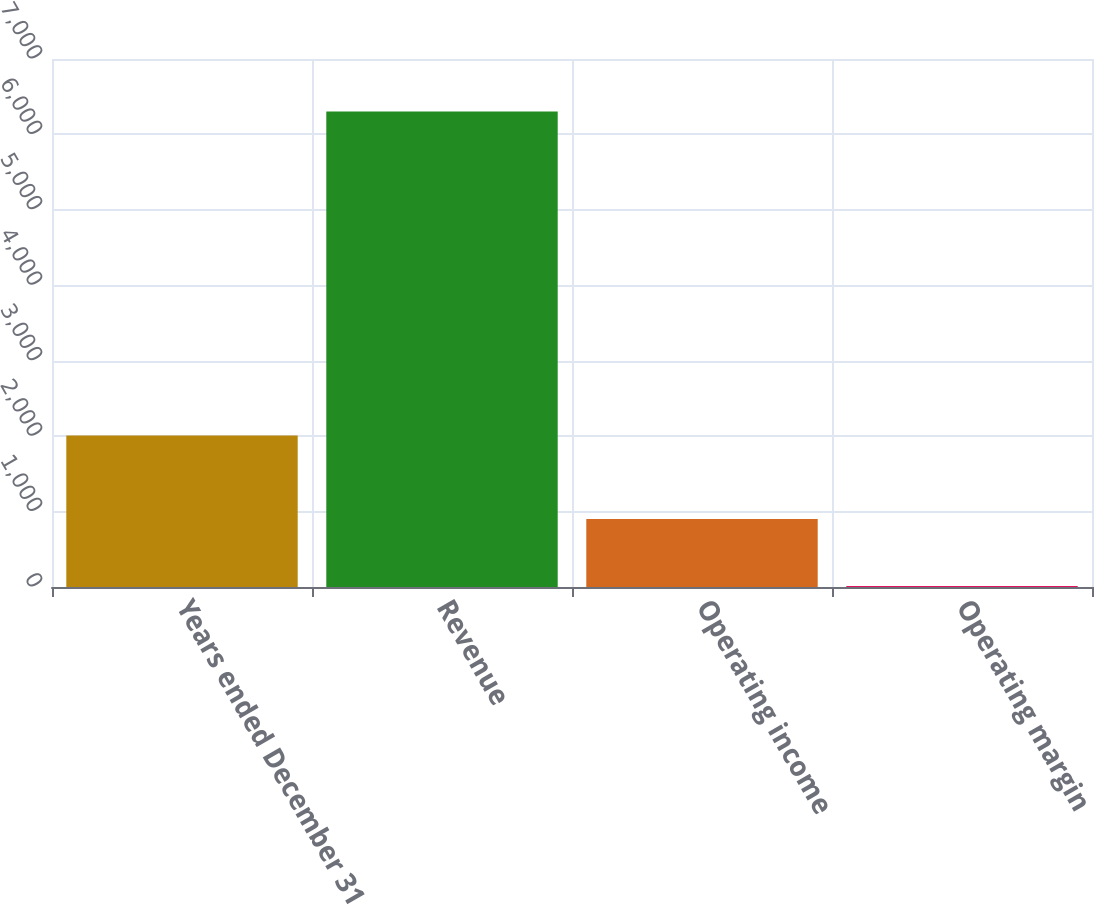Convert chart. <chart><loc_0><loc_0><loc_500><loc_500><bar_chart><fcel>Years ended December 31<fcel>Revenue<fcel>Operating income<fcel>Operating margin<nl><fcel>2009<fcel>6305<fcel>900<fcel>14.3<nl></chart> 